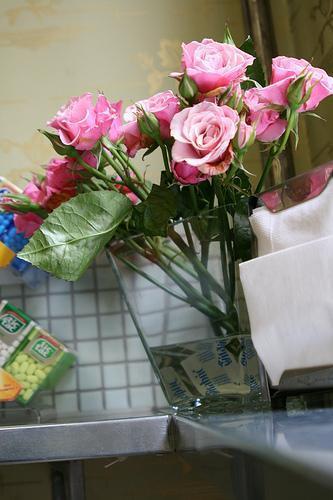How many vases are there?
Give a very brief answer. 1. 